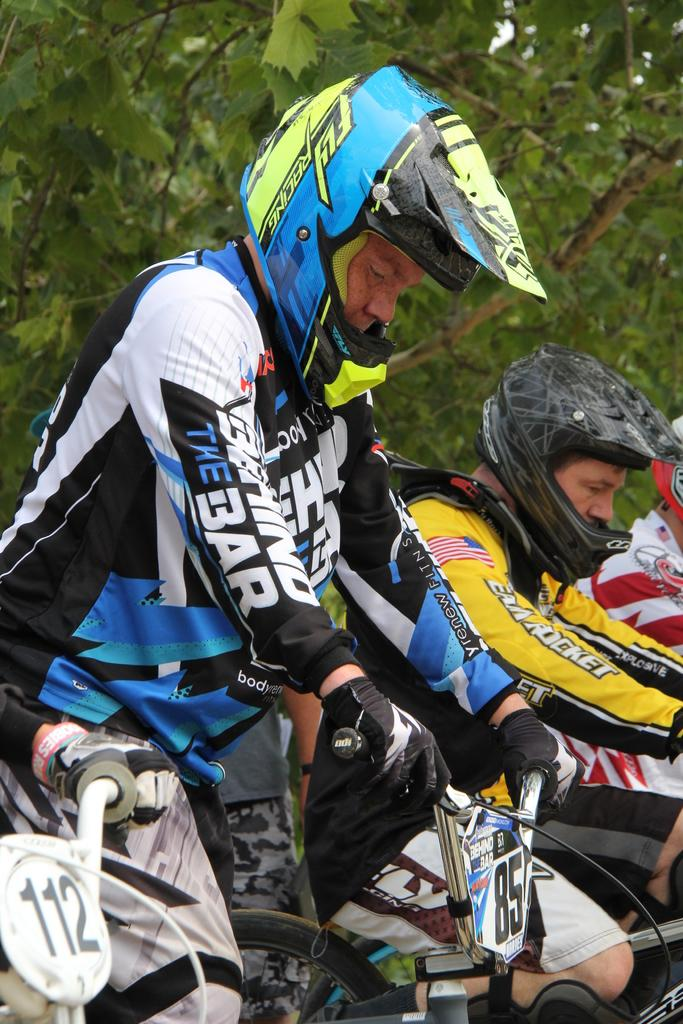Who or what can be seen in the image? There are people in the image. What are the people doing in the image? The people are sitting on bicycles. What can be seen in the distance in the image? There are trees in the background of the image. Reasoning: Let' Let's think step by step in order to produce the conversation. We start by identifying the main subjects in the image, which are the people. Then, we describe what the people are doing, which is sitting on bicycles. Finally, we mention the background of the image, which includes trees. Each question is designed to elicit a specific detail about the image that is known from the provided facts. Absurd Question/Answer: How many quills are being used by the people in the image? There are no quills present in the image; the people are sitting on bicycles. What type of legs are visible on the people in the image? The question is unclear and seems to be asking about the physical legs of the people, which are not the focus of the image. The image shows people sitting on bicycles, and their legs are not the main subject. Are there any tents visible in the image? No, there are no tents present in the image; the people are sitting on bicycles in front of trees. 